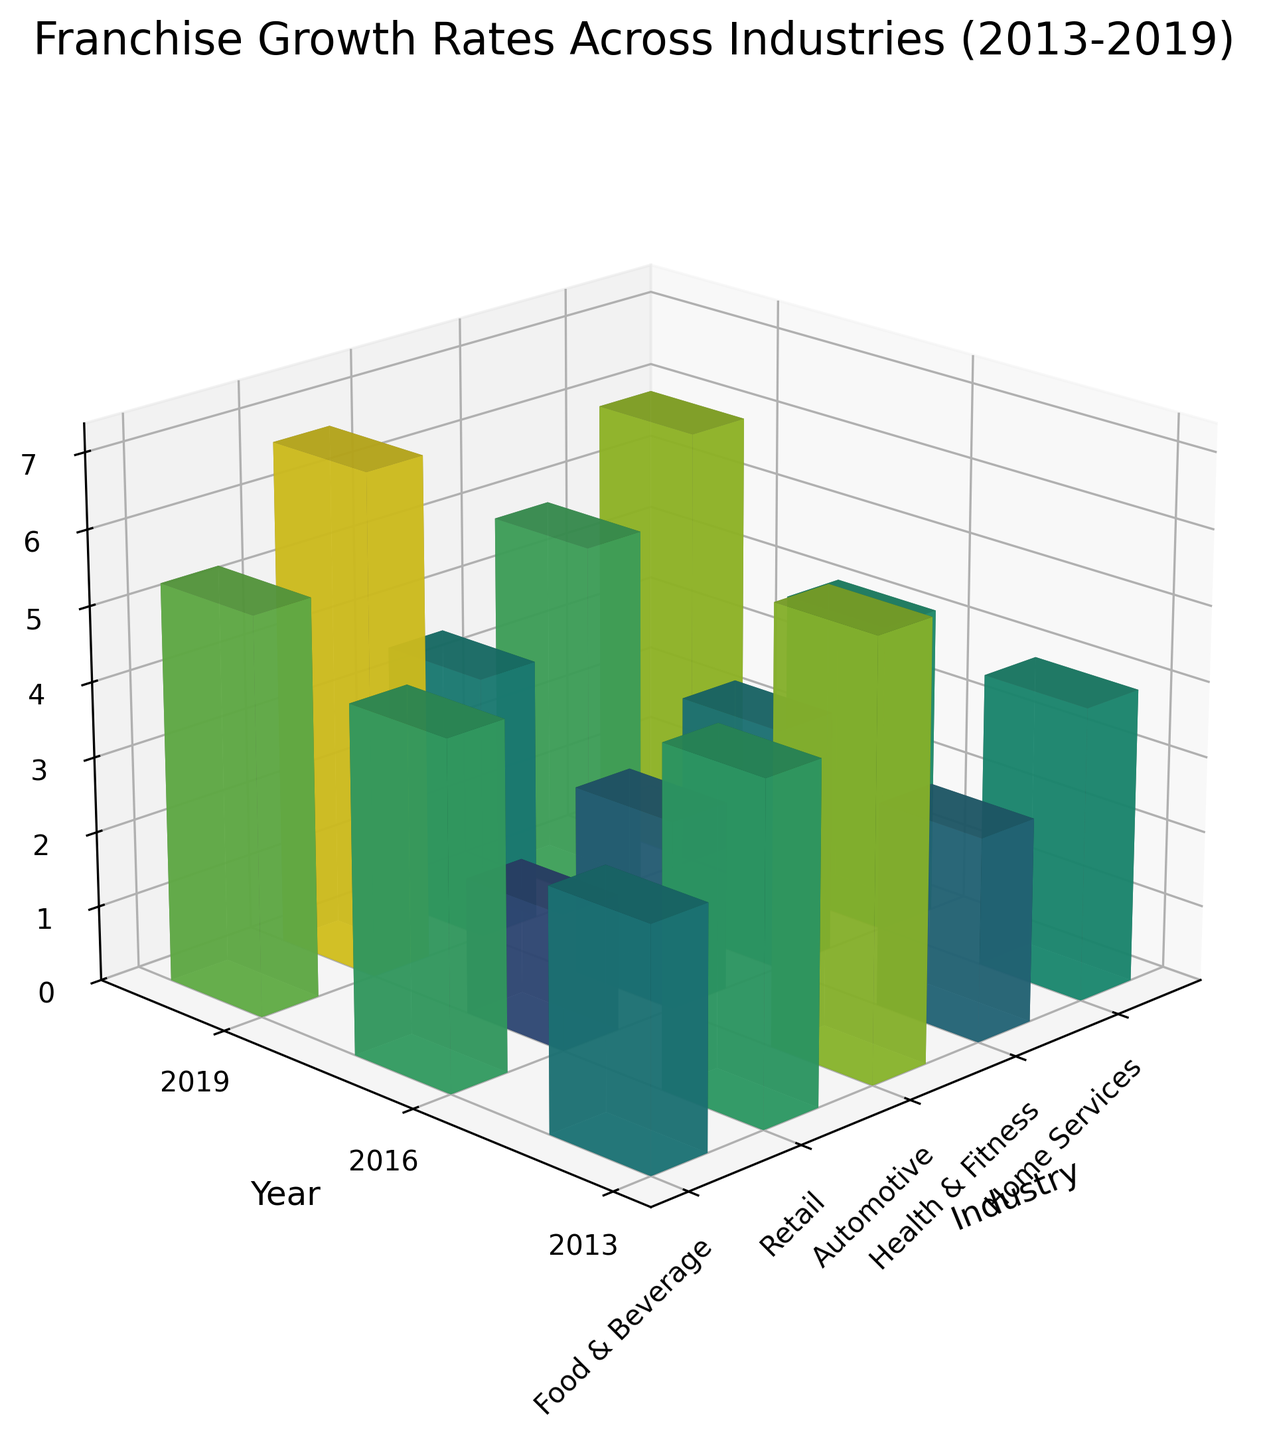how many industries are represented in the figure? There are 5 distinct industry labels on the x-axis, indicating the number of industries represented.
Answer: 5 what is the highest growth rate seen in the plot? By examining the z-axis scale and the height of the bars, the highest growth rate is just below 7%.
Answer: 6.7% which industry had the highest growth rate in 2019? By comparing the heights of the bars for each industry in 2019, 'Health & Fitness' has the highest bar.
Answer: Health & Fitness how much did the growth rate for 'Home Services' increase from 2013 to 2019? The difference can be calculated by subtracting the 2013 growth rate (3.5) from the 2019 growth rate (5.9) for 'Home Services'.
Answer: 2.4% which year had the overall lowest growth rate? By examining and comparing the heights of all bars across years, it's clear that 2013 had generally shorter bars.
Answer: 2013 what is the average growth rate for 'Retail' across the years depicted? Sum the growth rates for 'Retail' (2.7, 3.9, 4.6) and divide by the number of years (3).
Answer: 3.73% which industries showed continuous growth over the decade? By observing the heights of bars for all years, 'Food & Beverage', 'Retail', 'Health & Fitness', and 'Home Services' all show continuously increasing growth rates.
Answer: Food & Beverage, Retail, Health & Fitness, Home Services is there any industry that did not experience growth every year? Checking each industry's growth rates, 'Automotive' had the smallest overall growth, but still increased each year. No industry experienced a decline.
Answer: None what is the general trend in growth rate across all industries from 2013 to 2019? Observing the overall height of the bars, most industries exhibit an upward trend, indicating growth over time.
Answer: Upward trend how many data points are in the figure? Each industry has 3 data points (for each year: 2013, 2016, 2019) with 5 industries in total, making 3*5 = 15 data points.
Answer: 15 